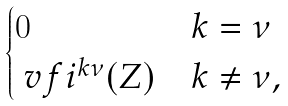<formula> <loc_0><loc_0><loc_500><loc_500>\begin{cases} 0 & k = \nu \\ \ v f i ^ { k \nu } ( Z ) & k \neq \nu , \end{cases}</formula> 